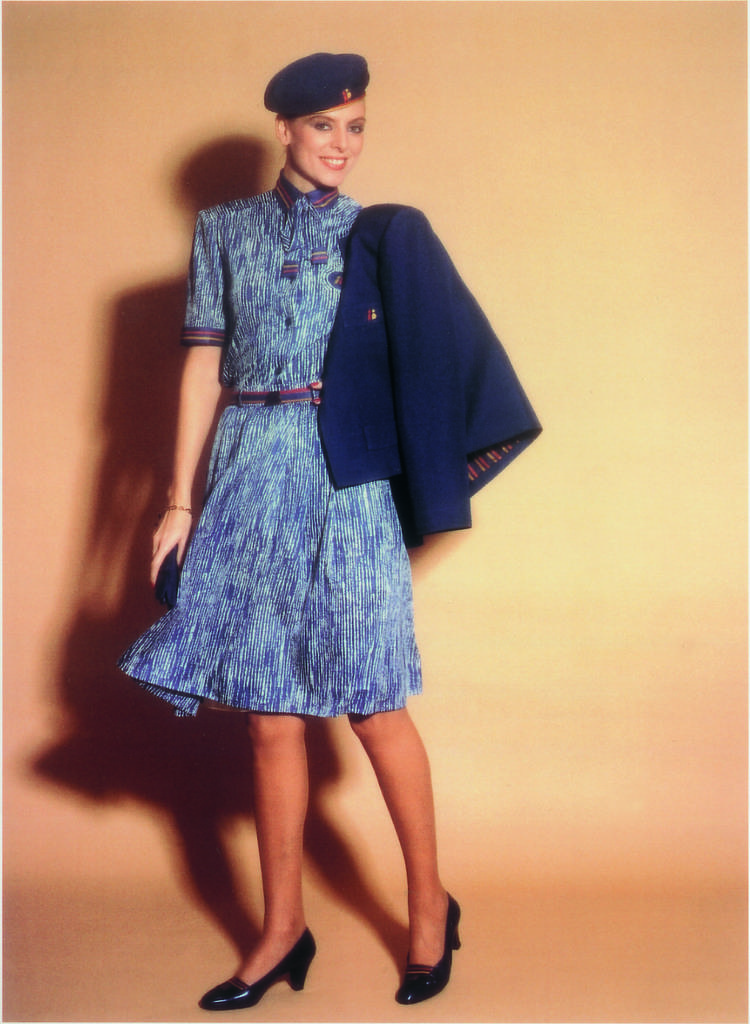What is the main subject of the image? The main subject of the image is a woman. What is the woman doing in the image? The woman is holding an object and standing on the floor. What is the woman's facial expression in the image? The woman is smiling in the image. What is the woman wearing on her head in the image? The woman is wearing a cap in the image. What can be seen in the background of the image? There is a shadow visible on the wall in the background of the image. What time does the clock in the image show? There is no clock present in the image. What type of pain is the woman experiencing in the image? There is no indication of pain in the image; the woman is smiling. 